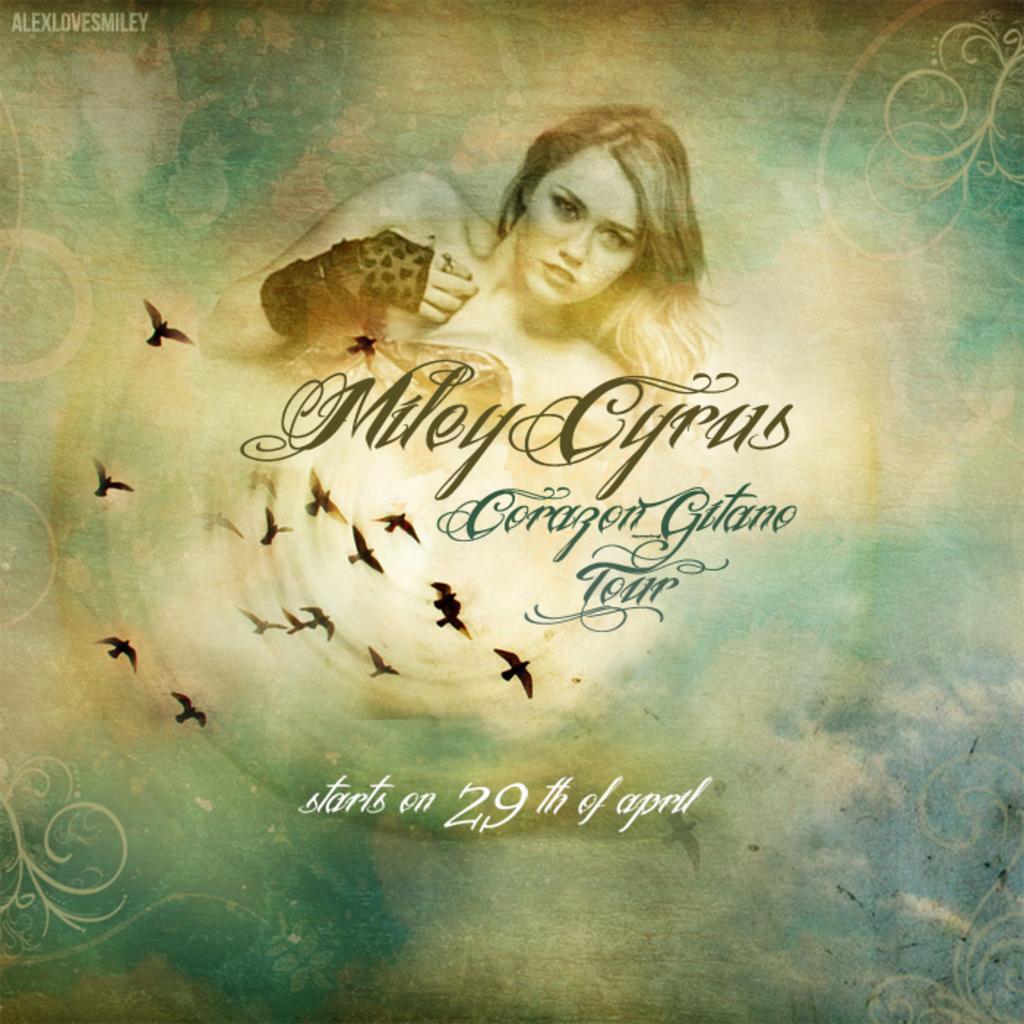When does miley cyrus go on tour?
Keep it short and to the point. April 29th. Who is going on tour?
Your response must be concise. Miley cyrus. 